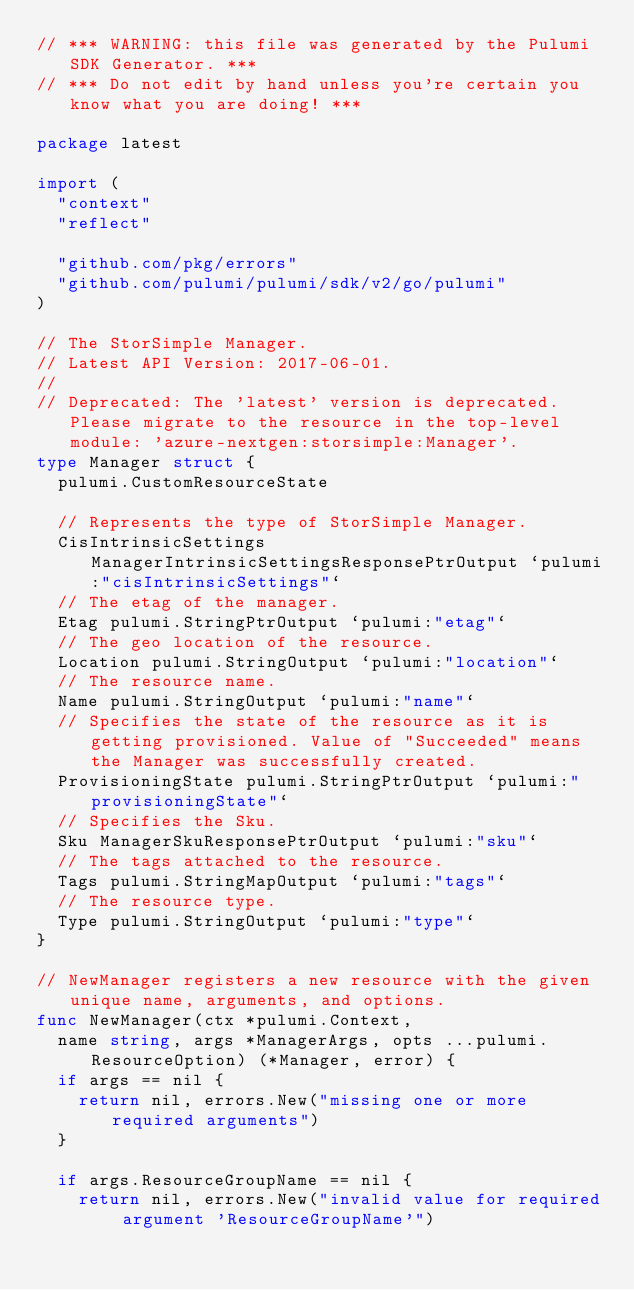Convert code to text. <code><loc_0><loc_0><loc_500><loc_500><_Go_>// *** WARNING: this file was generated by the Pulumi SDK Generator. ***
// *** Do not edit by hand unless you're certain you know what you are doing! ***

package latest

import (
	"context"
	"reflect"

	"github.com/pkg/errors"
	"github.com/pulumi/pulumi/sdk/v2/go/pulumi"
)

// The StorSimple Manager.
// Latest API Version: 2017-06-01.
//
// Deprecated: The 'latest' version is deprecated. Please migrate to the resource in the top-level module: 'azure-nextgen:storsimple:Manager'.
type Manager struct {
	pulumi.CustomResourceState

	// Represents the type of StorSimple Manager.
	CisIntrinsicSettings ManagerIntrinsicSettingsResponsePtrOutput `pulumi:"cisIntrinsicSettings"`
	// The etag of the manager.
	Etag pulumi.StringPtrOutput `pulumi:"etag"`
	// The geo location of the resource.
	Location pulumi.StringOutput `pulumi:"location"`
	// The resource name.
	Name pulumi.StringOutput `pulumi:"name"`
	// Specifies the state of the resource as it is getting provisioned. Value of "Succeeded" means the Manager was successfully created.
	ProvisioningState pulumi.StringPtrOutput `pulumi:"provisioningState"`
	// Specifies the Sku.
	Sku ManagerSkuResponsePtrOutput `pulumi:"sku"`
	// The tags attached to the resource.
	Tags pulumi.StringMapOutput `pulumi:"tags"`
	// The resource type.
	Type pulumi.StringOutput `pulumi:"type"`
}

// NewManager registers a new resource with the given unique name, arguments, and options.
func NewManager(ctx *pulumi.Context,
	name string, args *ManagerArgs, opts ...pulumi.ResourceOption) (*Manager, error) {
	if args == nil {
		return nil, errors.New("missing one or more required arguments")
	}

	if args.ResourceGroupName == nil {
		return nil, errors.New("invalid value for required argument 'ResourceGroupName'")</code> 